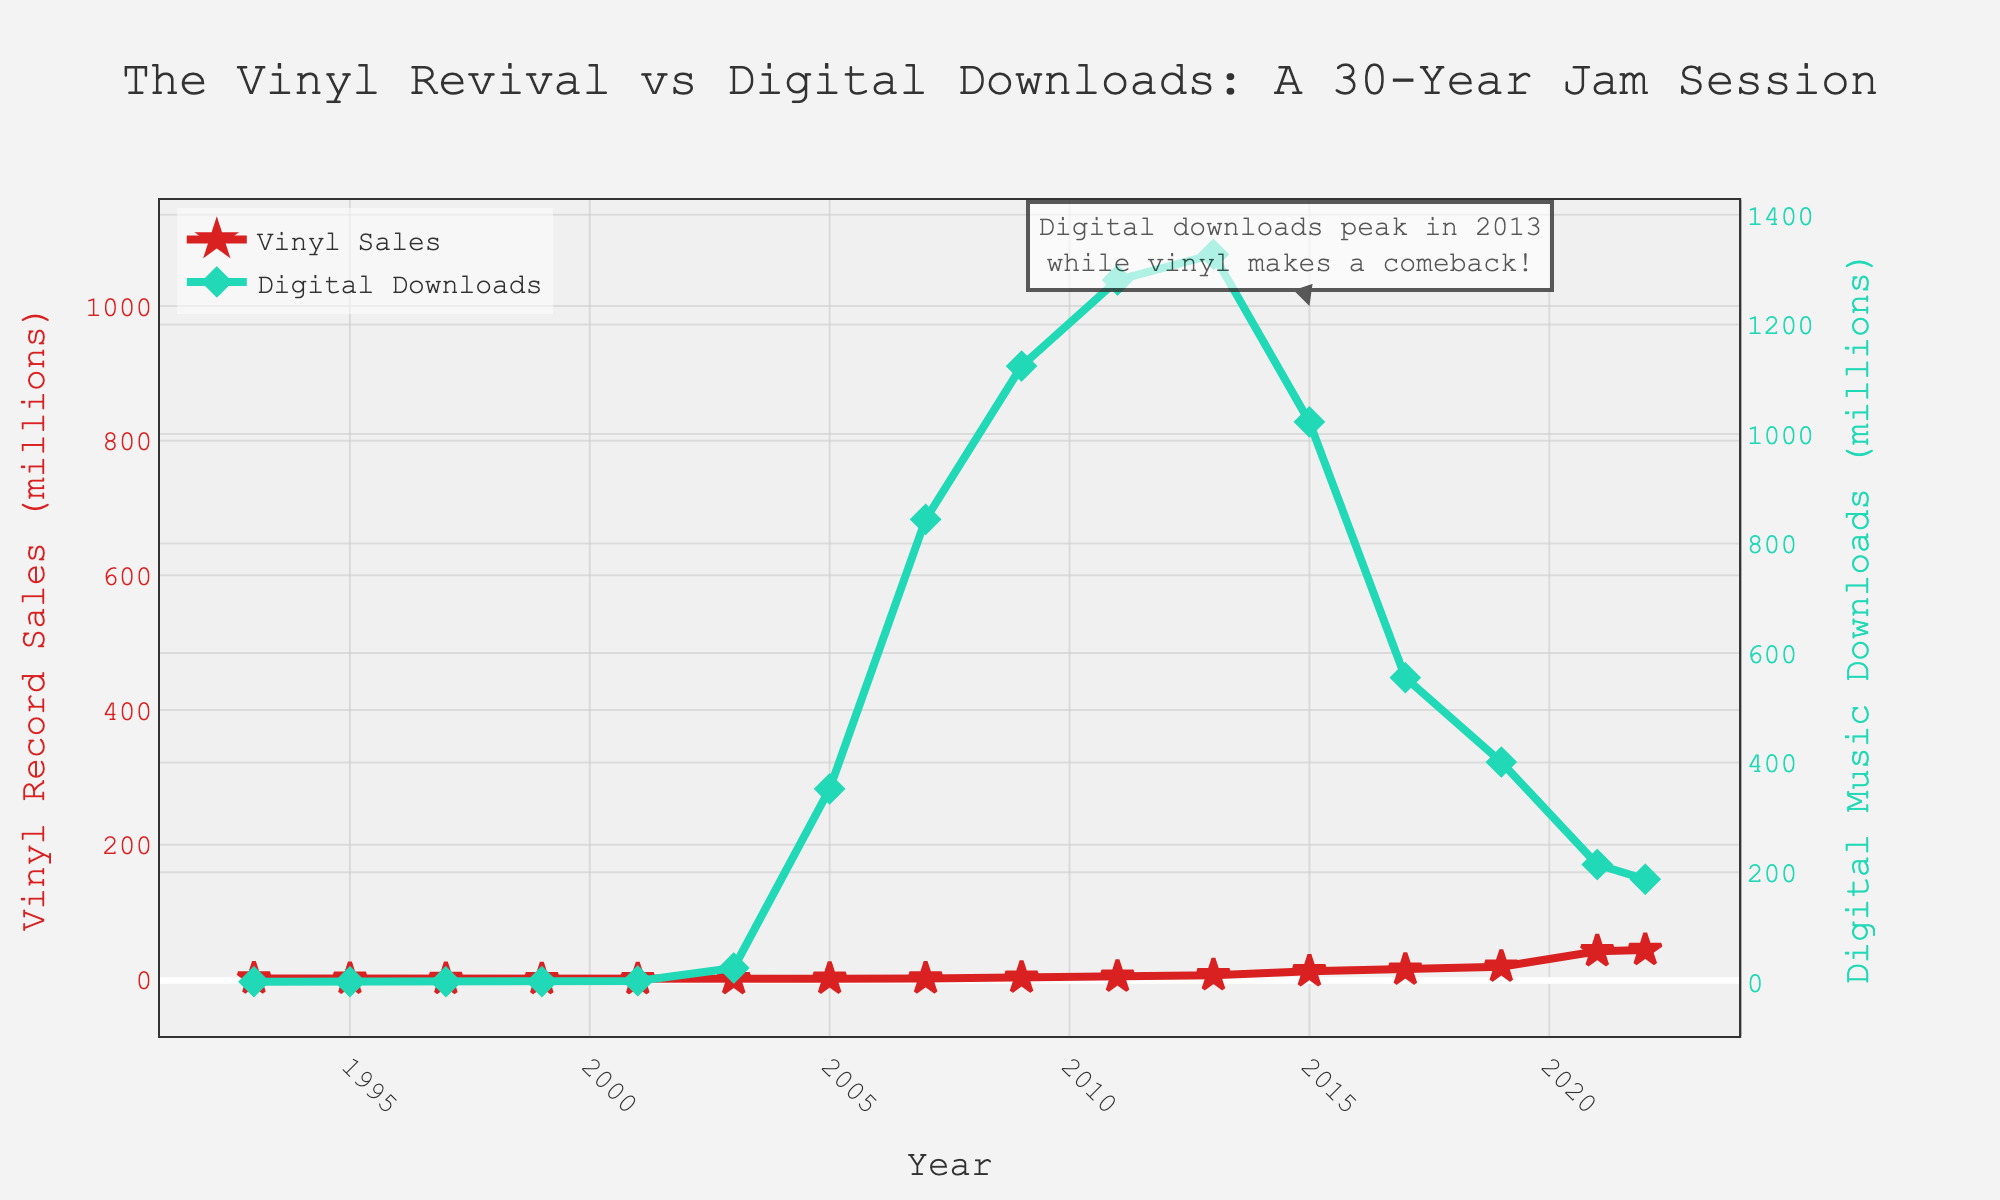Which year shows the peak of digital music downloads? The peak of digital music downloads is indicated by the highest point on the green line. Checking the values, it peaks in the year 2013.
Answer: 2013 In which years were vinyl record sales higher than digital music downloads? To find years where the red line (vinyl sales) exceeds the green line (digital downloads), we notice that only in the years 1993, 1995, 1997, and 2021, 2022 vinyl sales surpassed digital downloads.
Answer: 1993, 1995, 1997, 2021, 2022 By how much did vinyl sales increase from 2003 to 2022? Vinyl sales in 2003 were 0.3 million and increased to 43.5 million in 2022. The increase is 43.5 - 0.3 = 43.2 million.
Answer: 43.2 million Compare the trends of vinyl record sales and digital music downloads between 2001 and 2009. From 2001 to 2009, digital downloads increased significantly from 1.5 to 1124 million. Vinyl sales increased from 0.2 to 2.5 million. Both trends show growth, but digital downloads grew much faster.
Answer: Digital downloads grew faster What is notable about the trend observed in digital downloads after 2013, as compared to the vinyl sales trend? After 2013, digital music downloads started to decline while vinyl record sales continued to rise significantly. The green line (digital) slopes downward while the red line (vinyl) slopes upward.
Answer: Digital downloads declined, vinyl sales increased What year did vinyl record sales surpass 10 million for the first time? Checking the red line (vinyl sales) surpassing the 10 million value, we see this occurs for the first time in 2015.
Answer: 2015 How did the digital music downloads in 2003 compare with 2005? In 2003, digital downloads were 25 million, and in 2005, they increased to 352 million. Comparatively, digital downloads in 2005 were significantly higher than in 2003.
Answer: Higher in 2005 What are the minimum values of vinyl sales and digital downloads recorded in the dataset? The minimum vinyl sales are 0.2 million in 2001, and for digital downloads, the minimum is 0 in 1993, 1995, and 1997.
Answer: Vinyl: 0.2 million, Digital: 0 Which format showed a more dramatic change between the years 2019 and 2021? Comparing the red line for vinyl and the green line for digital downloads between 2019 and 2021, vinyl sales increased from 18.8 to 41.7 million, while digital downloads decreased from 401 to 214 million. Hence, vinyl showed a more dramatic increase.
Answer: Vinyl sales Which color represents the digital music downloads on the plot? The digital music downloads are represented by the green line with diamond markers on the plot.
Answer: Green 